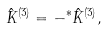Convert formula to latex. <formula><loc_0><loc_0><loc_500><loc_500>\hat { K } ^ { ( 3 ) } = - ^ { * } \hat { K } ^ { ( 3 ) } ,</formula> 